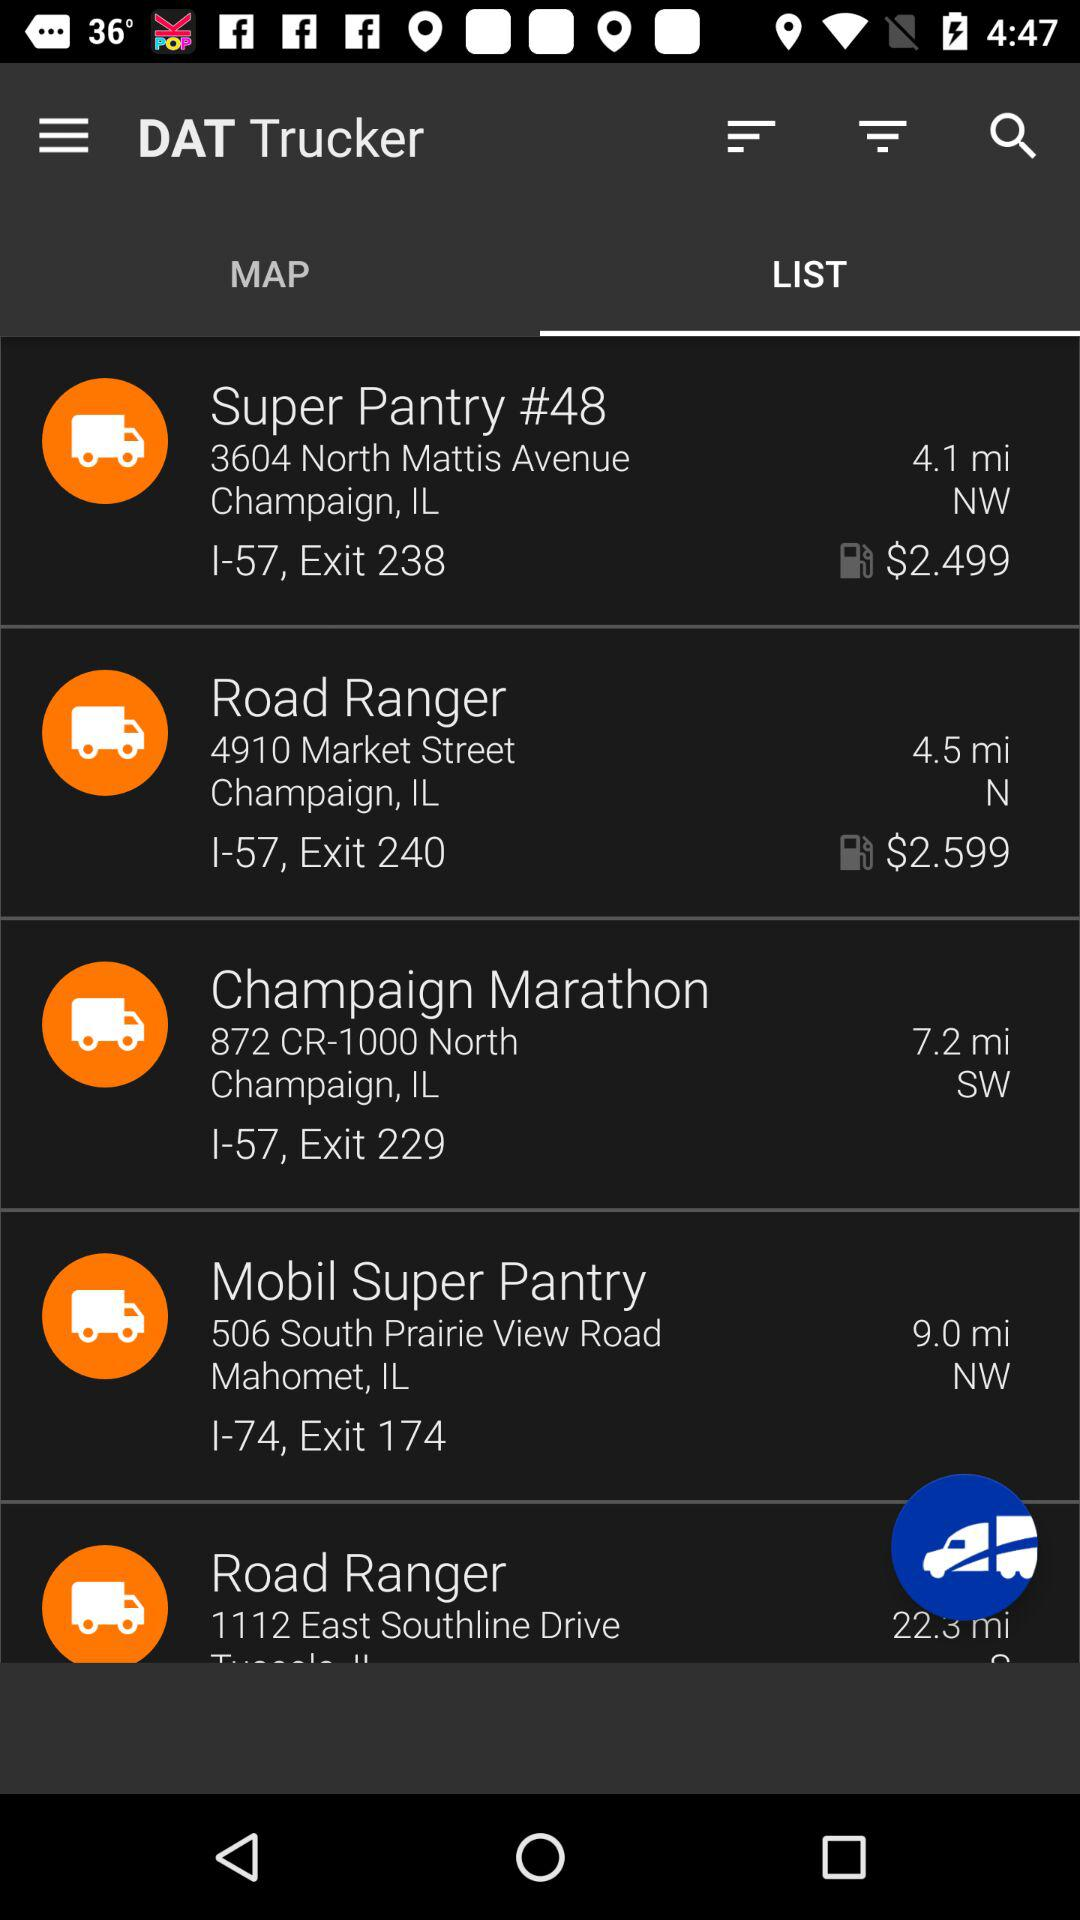What is the address of Mobil Super Pantry? The address is "506 South Prairie View Road Mahomet, IL I-74, Exit 174". 